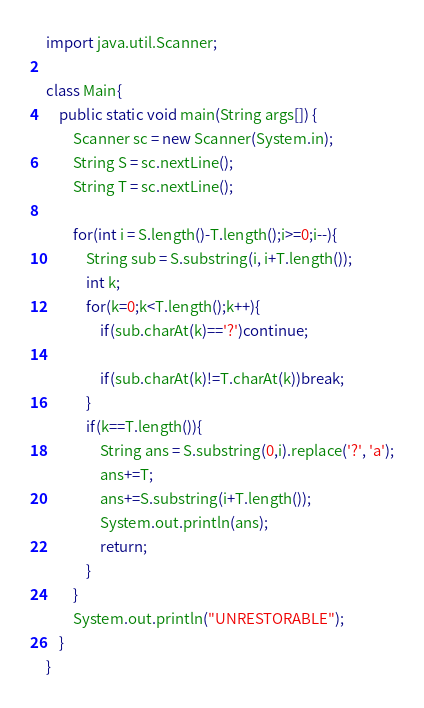Convert code to text. <code><loc_0><loc_0><loc_500><loc_500><_Java_>import java.util.Scanner;

class Main{
    public static void main(String args[]) {
        Scanner sc = new Scanner(System.in);
        String S = sc.nextLine();
        String T = sc.nextLine();

        for(int i = S.length()-T.length();i>=0;i--){
            String sub = S.substring(i, i+T.length());
            int k;
            for(k=0;k<T.length();k++){
                if(sub.charAt(k)=='?')continue;

                if(sub.charAt(k)!=T.charAt(k))break;
            }
            if(k==T.length()){
                String ans = S.substring(0,i).replace('?', 'a');
                ans+=T;
                ans+=S.substring(i+T.length());
                System.out.println(ans);
                return;
            }
        }
        System.out.println("UNRESTORABLE");
    }
}</code> 